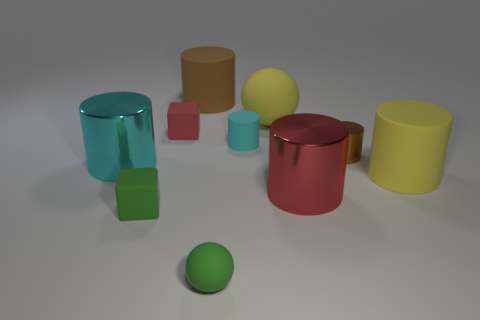Subtract 1 cylinders. How many cylinders are left? 5 Subtract all cyan cylinders. How many cylinders are left? 4 Subtract all cyan cylinders. Subtract all yellow spheres. How many cylinders are left? 4 Subtract all tiny brown shiny cylinders. How many cylinders are left? 5 Subtract all cylinders. How many objects are left? 4 Subtract all red cylinders. Subtract all brown objects. How many objects are left? 7 Add 5 green balls. How many green balls are left? 6 Add 3 small cylinders. How many small cylinders exist? 5 Subtract 2 cyan cylinders. How many objects are left? 8 